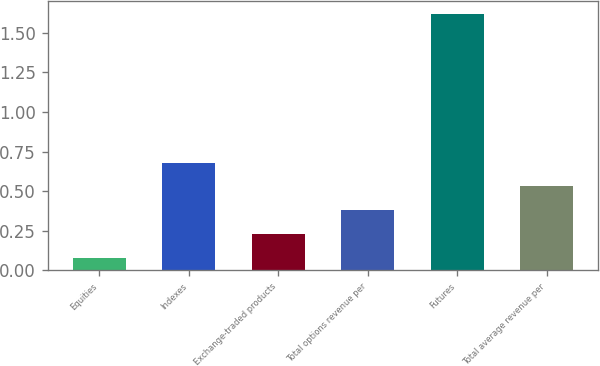<chart> <loc_0><loc_0><loc_500><loc_500><bar_chart><fcel>Equities<fcel>Indexes<fcel>Exchange-traded products<fcel>Total options revenue per<fcel>Futures<fcel>Total average revenue per<nl><fcel>0.08<fcel>0.68<fcel>0.23<fcel>0.38<fcel>1.62<fcel>0.53<nl></chart> 